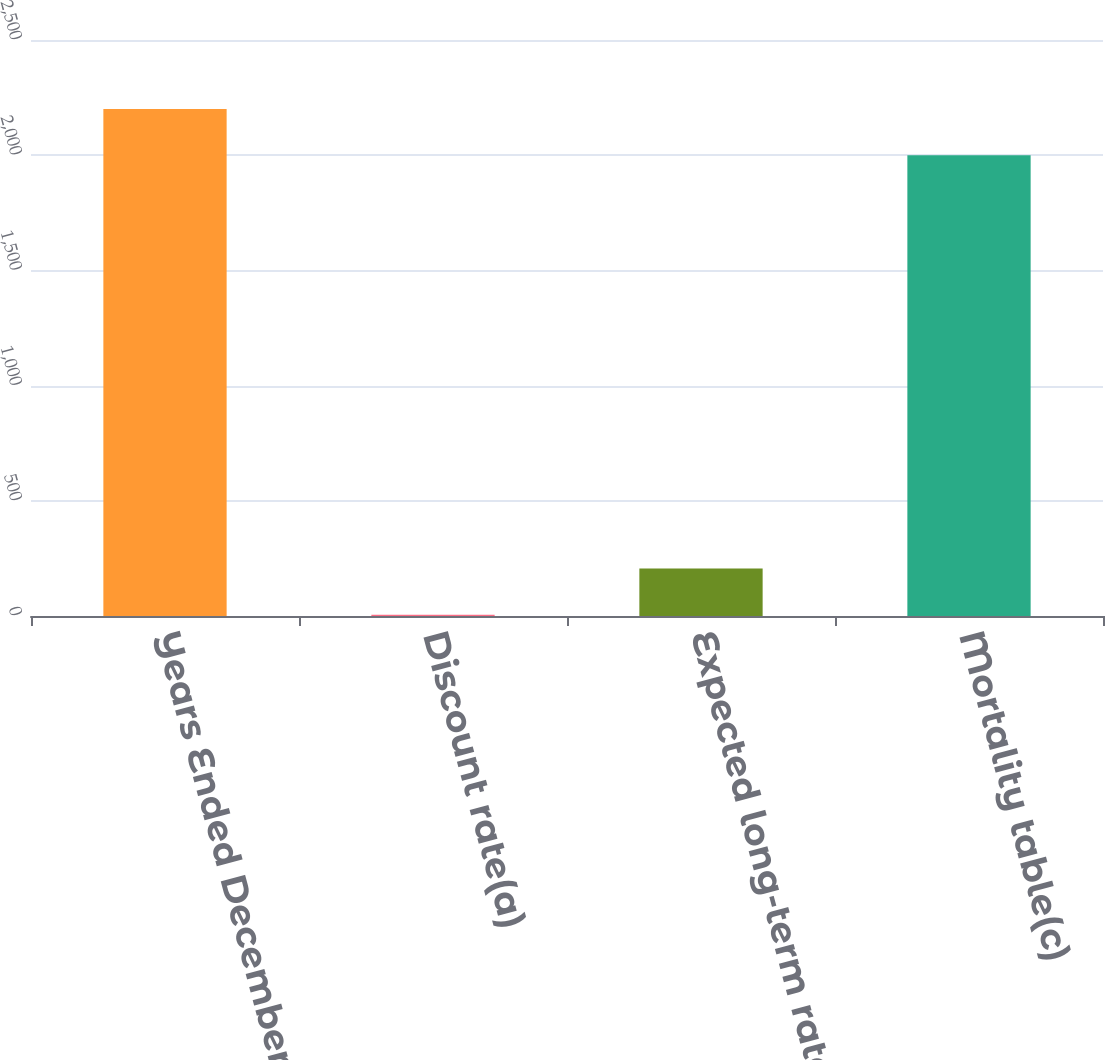Convert chart. <chart><loc_0><loc_0><loc_500><loc_500><bar_chart><fcel>Years Ended December 31<fcel>Discount rate(a)<fcel>Expected long-term rate of<fcel>Mortality table(c)<nl><fcel>2200.14<fcel>5.65<fcel>205.78<fcel>2000<nl></chart> 